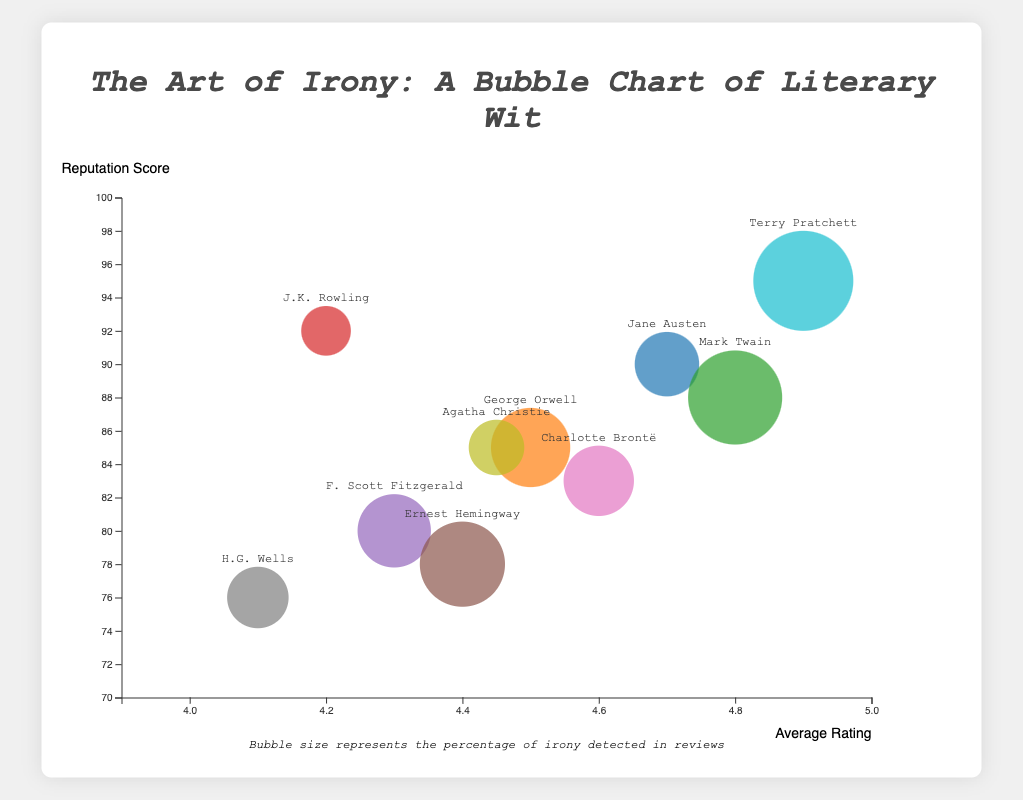What is the title of the bubble chart? The title is usually displayed at the top of the chart and summarizes what the chart represents. In this case, it reads "The Art of Irony: A Bubble Chart of Literary Wit."
Answer: The Art of Irony: A Bubble Chart of Literary Wit Which author has the highest average rating? To find the highest average rating, you look at the x-axis position of the bubbles and identify the one that is furthest to the right. Terry Pratchett's bubble is located at an average rating of 4.9, which is the highest.
Answer: Terry Pratchett What is the reputation score of the author with the highest irony percentage? First, identify which bubble has the largest size since bubble size represents irony percentage. Terry Pratchett has the largest bubble with an irony percentage of 27%. Looking vertically from this bubble to the y-axis reveals a reputation score of 95.
Answer: 95 Which authors have an irony percentage above 20%? To find authors with irony above 20%, explore the larger bubbles. Mark Twain (25%), Ernest Hemingway (22%), and Terry Pratchett (27%) have bubbles indicating more than 20% irony.
Answer: Mark Twain, Ernest Hemingway, Terry Pratchett What is the average reputation score for Jane Austen and Agatha Christie? Locate Jane Austen and Agatha Christie bubbles. Jane Austen has a reputation score of 90, and Agatha Christie has 85. The average is calculated as (90 + 85) / 2 = 87.5.
Answer: 87.5 Which author has a lower reputation score, George Orwell or J.K. Rowling? Compare the positions of George Orwell and J.K. Rowling bubbles on the y-axis. George Orwell has a reputation score of 85, and J.K. Rowling has 92. Therefore, George Orwell's score is lower.
Answer: George Orwell Are the authors with the highest and lowest irony percentages both above the average reputation score? The highest irony percentage is by Terry Pratchett (27%), and the lowest is by J.K. Rowling (10%). Terry Pratchett's reputation score is 95, and J.K. Rowling's is 92. The average reputation score can be calculated roughly around the middle of the y-axis range. Since both scores are above the mid-point, they are above the average.
Answer: Yes Which author has an irony percentage closest to the median irony percentage of all authors? To find the median of irony percentages, list them: 10, 12, 14, 15, 17, 18, 20, 22, 25, and 27. The middle values are 17 and 18, so the median is (17+18)/2 = 17.5. Charlotte Brontë with 17% is closest to 17.5%.
Answer: Charlotte Brontë Which author has a higher irony percentage, George Orwell or F. Scott Fitzgerald? Compare the bubble sizes of George Orwell and F. Scott Fitzgerald. George Orwell has an irony percentage of 20%, while F. Scott Fitzgerald has 18%. So, George Orwell has a higher irony percentage.
Answer: George Orwell 